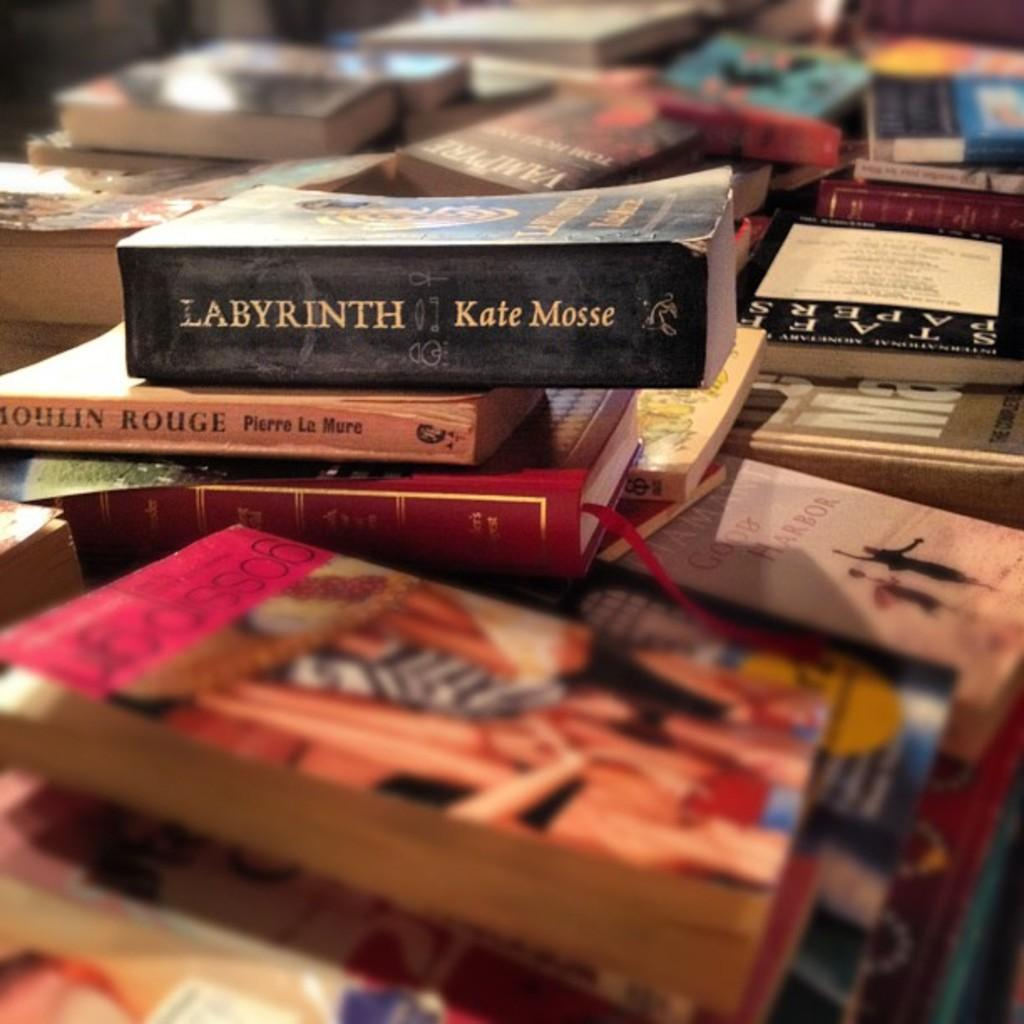What is the main subject of the image? The main subject of the image is a group of books. Can you describe the books in the image? Unfortunately, the image does not provide enough detail to describe the books. Are there any other objects or elements visible in the image? The provided facts do not mention any other objects or elements in the image. What type of crow is perched on top of the books in the image? There is no crow present in the image; the main subject is a group of books. 